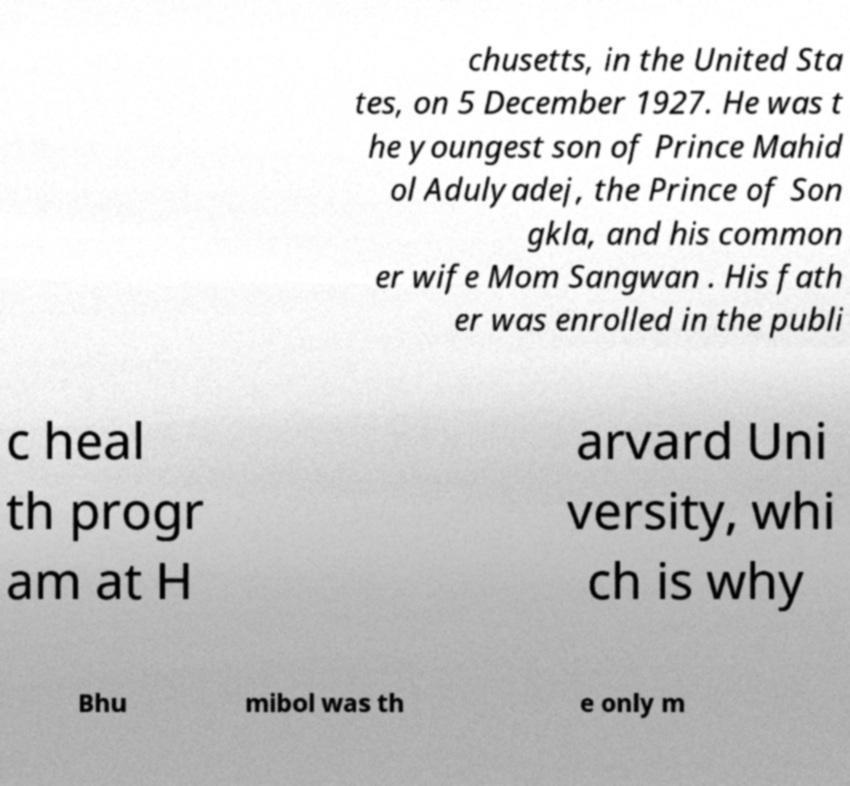Please identify and transcribe the text found in this image. chusetts, in the United Sta tes, on 5 December 1927. He was t he youngest son of Prince Mahid ol Adulyadej, the Prince of Son gkla, and his common er wife Mom Sangwan . His fath er was enrolled in the publi c heal th progr am at H arvard Uni versity, whi ch is why Bhu mibol was th e only m 